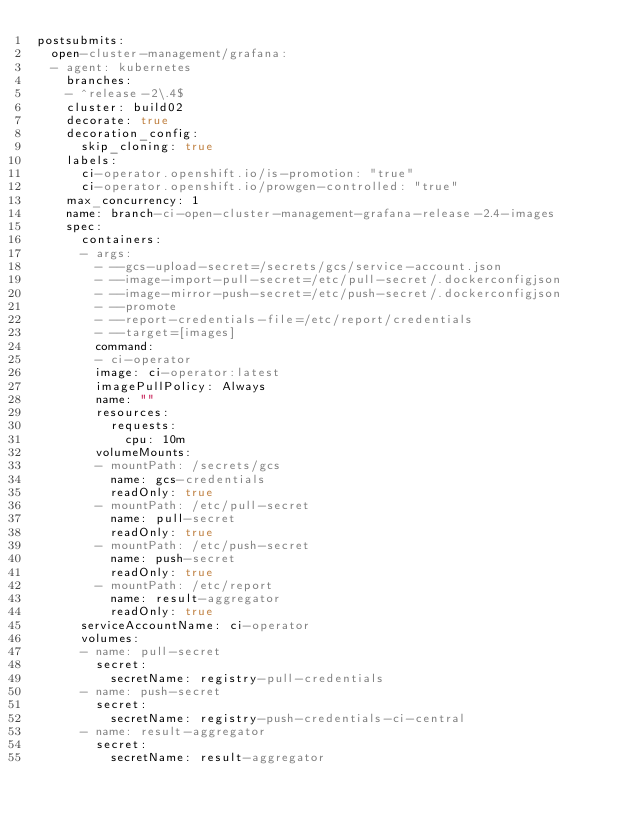Convert code to text. <code><loc_0><loc_0><loc_500><loc_500><_YAML_>postsubmits:
  open-cluster-management/grafana:
  - agent: kubernetes
    branches:
    - ^release-2\.4$
    cluster: build02
    decorate: true
    decoration_config:
      skip_cloning: true
    labels:
      ci-operator.openshift.io/is-promotion: "true"
      ci-operator.openshift.io/prowgen-controlled: "true"
    max_concurrency: 1
    name: branch-ci-open-cluster-management-grafana-release-2.4-images
    spec:
      containers:
      - args:
        - --gcs-upload-secret=/secrets/gcs/service-account.json
        - --image-import-pull-secret=/etc/pull-secret/.dockerconfigjson
        - --image-mirror-push-secret=/etc/push-secret/.dockerconfigjson
        - --promote
        - --report-credentials-file=/etc/report/credentials
        - --target=[images]
        command:
        - ci-operator
        image: ci-operator:latest
        imagePullPolicy: Always
        name: ""
        resources:
          requests:
            cpu: 10m
        volumeMounts:
        - mountPath: /secrets/gcs
          name: gcs-credentials
          readOnly: true
        - mountPath: /etc/pull-secret
          name: pull-secret
          readOnly: true
        - mountPath: /etc/push-secret
          name: push-secret
          readOnly: true
        - mountPath: /etc/report
          name: result-aggregator
          readOnly: true
      serviceAccountName: ci-operator
      volumes:
      - name: pull-secret
        secret:
          secretName: registry-pull-credentials
      - name: push-secret
        secret:
          secretName: registry-push-credentials-ci-central
      - name: result-aggregator
        secret:
          secretName: result-aggregator
</code> 